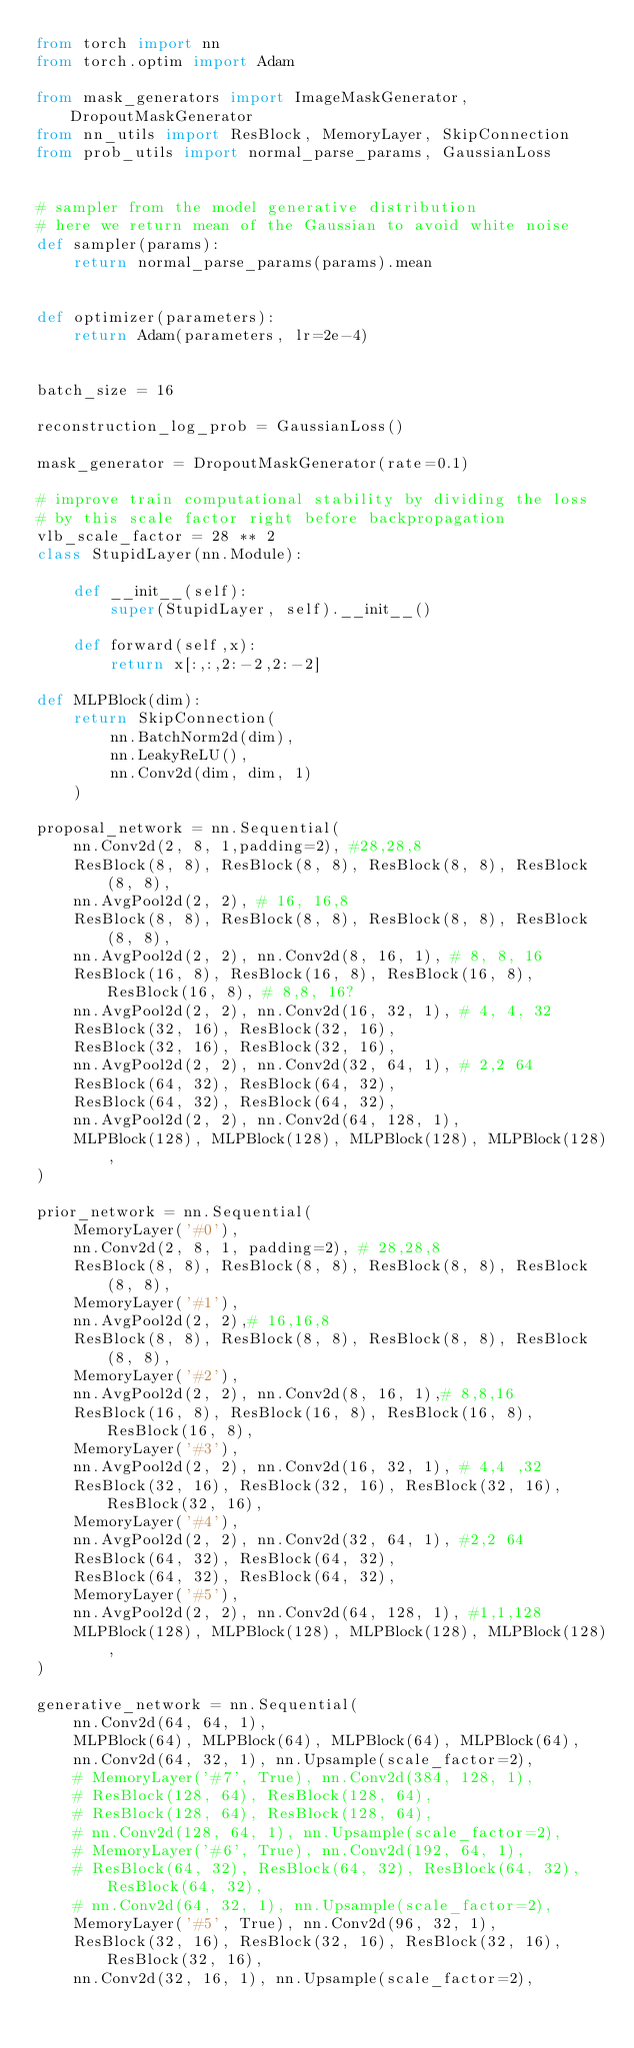Convert code to text. <code><loc_0><loc_0><loc_500><loc_500><_Python_>from torch import nn
from torch.optim import Adam

from mask_generators import ImageMaskGenerator, DropoutMaskGenerator
from nn_utils import ResBlock, MemoryLayer, SkipConnection
from prob_utils import normal_parse_params, GaussianLoss


# sampler from the model generative distribution
# here we return mean of the Gaussian to avoid white noise
def sampler(params):
    return normal_parse_params(params).mean


def optimizer(parameters):
    return Adam(parameters, lr=2e-4)


batch_size = 16

reconstruction_log_prob = GaussianLoss()

mask_generator = DropoutMaskGenerator(rate=0.1)

# improve train computational stability by dividing the loss
# by this scale factor right before backpropagation
vlb_scale_factor = 28 ** 2
class StupidLayer(nn.Module):

    def __init__(self):
        super(StupidLayer, self).__init__()

    def forward(self,x):
        return x[:,:,2:-2,2:-2]

def MLPBlock(dim):
    return SkipConnection(
        nn.BatchNorm2d(dim),
        nn.LeakyReLU(),
        nn.Conv2d(dim, dim, 1)
    )

proposal_network = nn.Sequential(
    nn.Conv2d(2, 8, 1,padding=2), #28,28,8
    ResBlock(8, 8), ResBlock(8, 8), ResBlock(8, 8), ResBlock(8, 8),
    nn.AvgPool2d(2, 2), # 16, 16,8
    ResBlock(8, 8), ResBlock(8, 8), ResBlock(8, 8), ResBlock(8, 8),
    nn.AvgPool2d(2, 2), nn.Conv2d(8, 16, 1), # 8, 8, 16
    ResBlock(16, 8), ResBlock(16, 8), ResBlock(16, 8), ResBlock(16, 8), # 8,8, 16?
    nn.AvgPool2d(2, 2), nn.Conv2d(16, 32, 1), # 4, 4, 32
    ResBlock(32, 16), ResBlock(32, 16),
    ResBlock(32, 16), ResBlock(32, 16),
    nn.AvgPool2d(2, 2), nn.Conv2d(32, 64, 1), # 2,2 64
    ResBlock(64, 32), ResBlock(64, 32),
    ResBlock(64, 32), ResBlock(64, 32),
    nn.AvgPool2d(2, 2), nn.Conv2d(64, 128, 1),
    MLPBlock(128), MLPBlock(128), MLPBlock(128), MLPBlock(128),
)

prior_network = nn.Sequential(
    MemoryLayer('#0'),
    nn.Conv2d(2, 8, 1, padding=2), # 28,28,8
    ResBlock(8, 8), ResBlock(8, 8), ResBlock(8, 8), ResBlock(8, 8),
    MemoryLayer('#1'),
    nn.AvgPool2d(2, 2),# 16,16,8
    ResBlock(8, 8), ResBlock(8, 8), ResBlock(8, 8), ResBlock(8, 8),
    MemoryLayer('#2'),
    nn.AvgPool2d(2, 2), nn.Conv2d(8, 16, 1),# 8,8,16
    ResBlock(16, 8), ResBlock(16, 8), ResBlock(16, 8), ResBlock(16, 8),
    MemoryLayer('#3'),
    nn.AvgPool2d(2, 2), nn.Conv2d(16, 32, 1), # 4,4 ,32
    ResBlock(32, 16), ResBlock(32, 16), ResBlock(32, 16), ResBlock(32, 16),
    MemoryLayer('#4'),
    nn.AvgPool2d(2, 2), nn.Conv2d(32, 64, 1), #2,2 64
    ResBlock(64, 32), ResBlock(64, 32),
    ResBlock(64, 32), ResBlock(64, 32),
    MemoryLayer('#5'),
    nn.AvgPool2d(2, 2), nn.Conv2d(64, 128, 1), #1,1,128
    MLPBlock(128), MLPBlock(128), MLPBlock(128), MLPBlock(128),
)

generative_network = nn.Sequential(
    nn.Conv2d(64, 64, 1),
    MLPBlock(64), MLPBlock(64), MLPBlock(64), MLPBlock(64),
    nn.Conv2d(64, 32, 1), nn.Upsample(scale_factor=2),
    # MemoryLayer('#7', True), nn.Conv2d(384, 128, 1),
    # ResBlock(128, 64), ResBlock(128, 64),
    # ResBlock(128, 64), ResBlock(128, 64),
    # nn.Conv2d(128, 64, 1), nn.Upsample(scale_factor=2),
    # MemoryLayer('#6', True), nn.Conv2d(192, 64, 1),
    # ResBlock(64, 32), ResBlock(64, 32), ResBlock(64, 32), ResBlock(64, 32),
    # nn.Conv2d(64, 32, 1), nn.Upsample(scale_factor=2),
    MemoryLayer('#5', True), nn.Conv2d(96, 32, 1),
    ResBlock(32, 16), ResBlock(32, 16), ResBlock(32, 16), ResBlock(32, 16),
    nn.Conv2d(32, 16, 1), nn.Upsample(scale_factor=2),</code> 